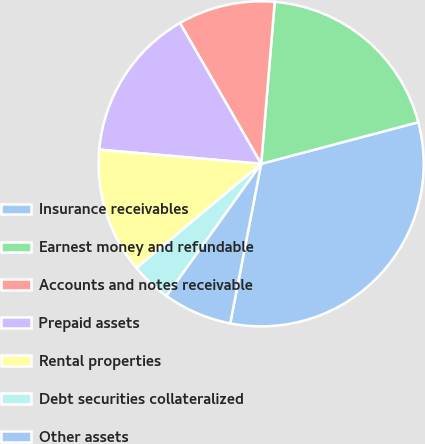Convert chart to OTSL. <chart><loc_0><loc_0><loc_500><loc_500><pie_chart><fcel>Insurance receivables<fcel>Earnest money and refundable<fcel>Accounts and notes receivable<fcel>Prepaid assets<fcel>Rental properties<fcel>Debt securities collateralized<fcel>Other assets<nl><fcel>32.17%<fcel>19.55%<fcel>9.66%<fcel>15.28%<fcel>12.47%<fcel>4.03%<fcel>6.84%<nl></chart> 